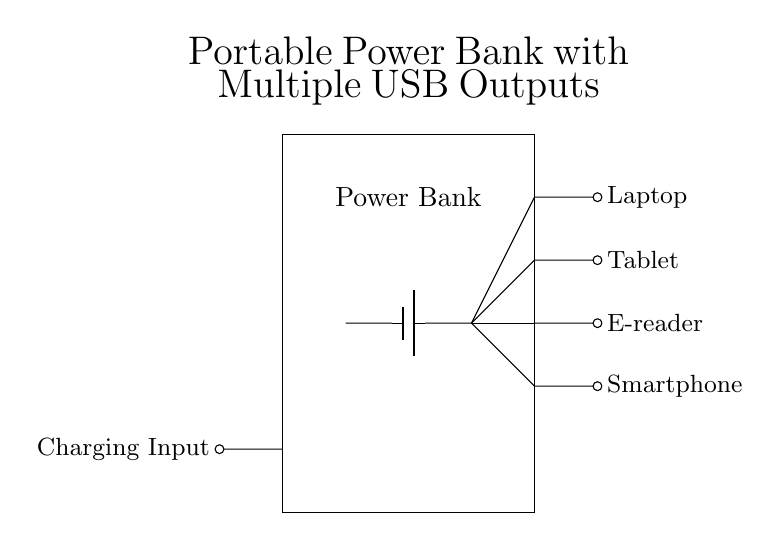What is the main component of this power bank circuit? The main component is the battery, which supplies the power needed for charging the devices connected to the USB outputs. This can be identified as the central element in the circuit diagram, typically depicted as a rectangular symbol with positive and negative terminals.
Answer: Battery How many USB outputs are present in this design? There are four USB outputs shown in the diagram, each connected to a different writing device such as a laptop, tablet, e-reader, and smartphone. This can be counted directly from the short connections extending from the power line in the circuit.
Answer: Four What is the function of the charging input in this circuit? The charging input serves the purpose of allowing the power bank to be recharged or supplied with power from an external source. It provides the energy needed to replenish the battery's charge after it has been used to power the USB outputs.
Answer: Recharge Which device outputs the most power based on typical usage? The laptop usually requires the most power compared to the other devices, such as a smartphone or e-reader. This assumption is based on typical power consumption needs, where laptops typically have higher power demands.
Answer: Laptop What type of circuit configuration is used in this power bank diagram? The circuit configuration is a parallel circuit, as evidenced by the multiple USB outputs stemming from a single battery source, allowing simultaneous charging of multiple devices. In parallel circuits, each load operates independently.
Answer: Parallel How is the battery connected to the USB outputs? The battery is connected to the USB outputs through four individual connections, demonstrating that each output can draw power independently from the same battery source without affecting the others. Each connection can be traced clearly in the circuit diagram from the battery to the outputs.
Answer: Multiple connections 